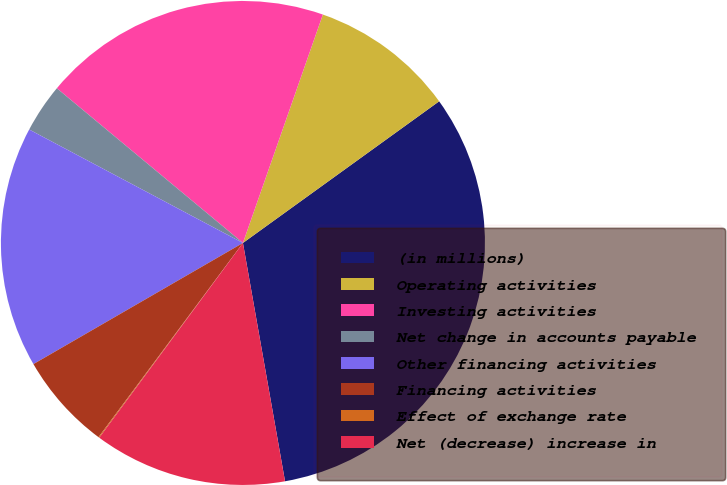Convert chart to OTSL. <chart><loc_0><loc_0><loc_500><loc_500><pie_chart><fcel>(in millions)<fcel>Operating activities<fcel>Investing activities<fcel>Net change in accounts payable<fcel>Other financing activities<fcel>Financing activities<fcel>Effect of exchange rate<fcel>Net (decrease) increase in<nl><fcel>32.17%<fcel>9.69%<fcel>19.32%<fcel>3.27%<fcel>16.11%<fcel>6.48%<fcel>0.06%<fcel>12.9%<nl></chart> 